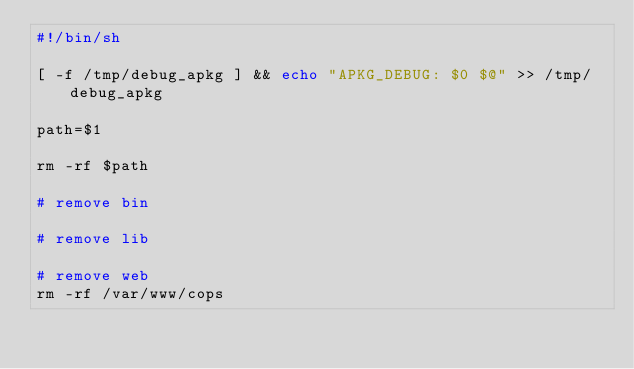Convert code to text. <code><loc_0><loc_0><loc_500><loc_500><_Bash_>#!/bin/sh

[ -f /tmp/debug_apkg ] && echo "APKG_DEBUG: $0 $@" >> /tmp/debug_apkg

path=$1

rm -rf $path

# remove bin

# remove lib

# remove web
rm -rf /var/www/cops
</code> 